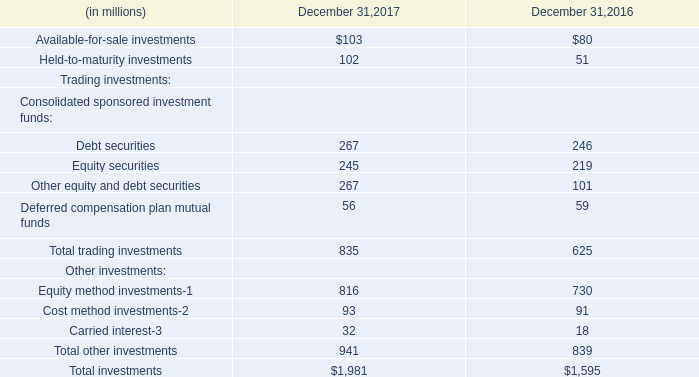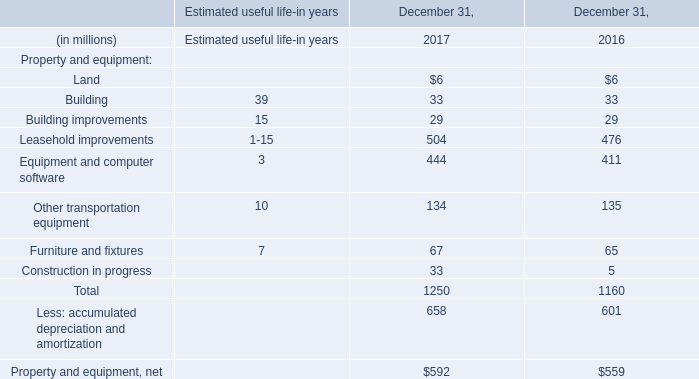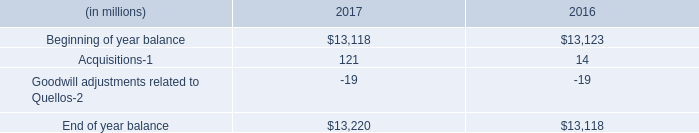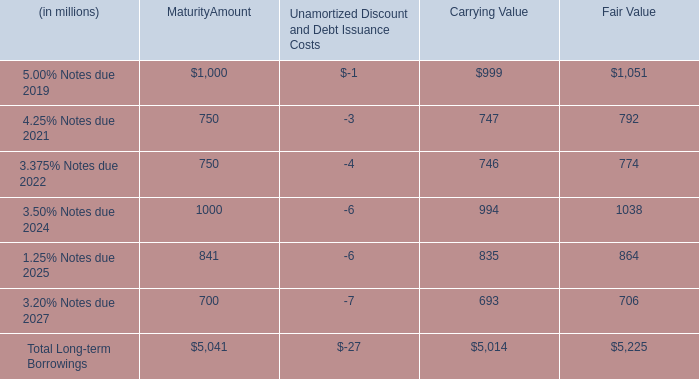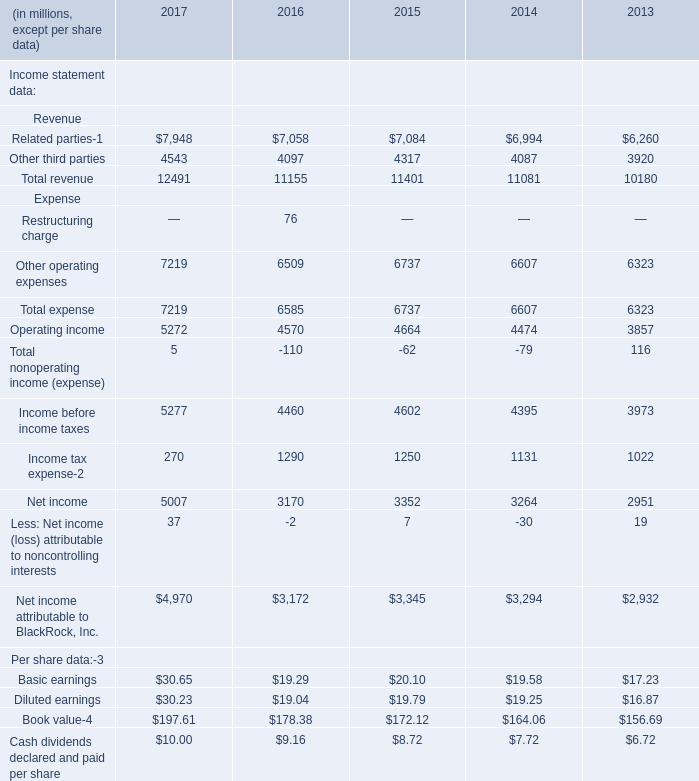what's the total amount of Beginning of year balance of 2017, and Other operating expenses Expense of 2013 ? 
Computations: (13118.0 + 6323.0)
Answer: 19441.0. 